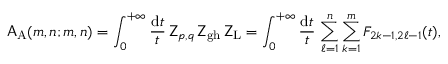Convert formula to latex. <formula><loc_0><loc_0><loc_500><loc_500>A _ { A } ( m , n ; m , n ) = \int _ { 0 } ^ { + \infty } \frac { d t } { t } \, Z _ { p , q } \, Z _ { g h } \, Z _ { L } = \int _ { 0 } ^ { + \infty } \frac { d t } { t } \, \sum _ { \ell = 1 } ^ { n } \sum _ { k = 1 } ^ { m } F _ { 2 k - 1 , 2 \ell - 1 } ( t ) ,</formula> 